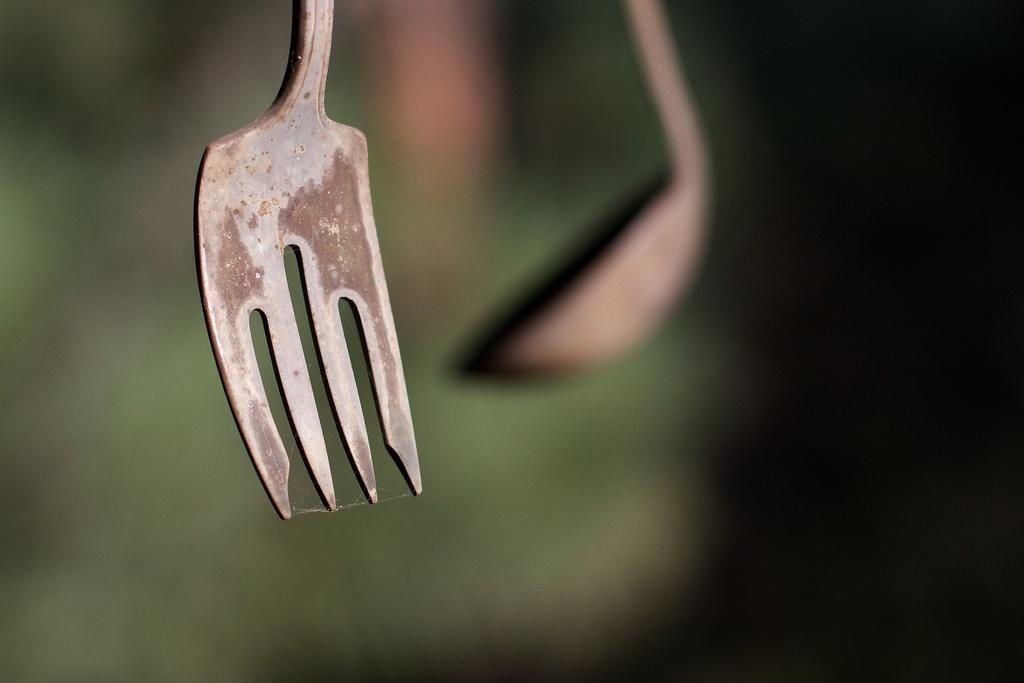What utensil is located in the front of the image? There is a fork in the front of the image. What utensil can be seen in the background of the image? There is a spoon in the background of the image. How would you describe the appearance of the background in the image? The background of the image appears blurry. How many clams are sitting on the table in the image? There are no clams present in the image. What level of experience does the beginner have with using the utensils in the image? The image does not provide information about the experience level of any individuals using the utensils. Are there any dinosaurs visible in the image? There are no dinosaurs present in the image. 